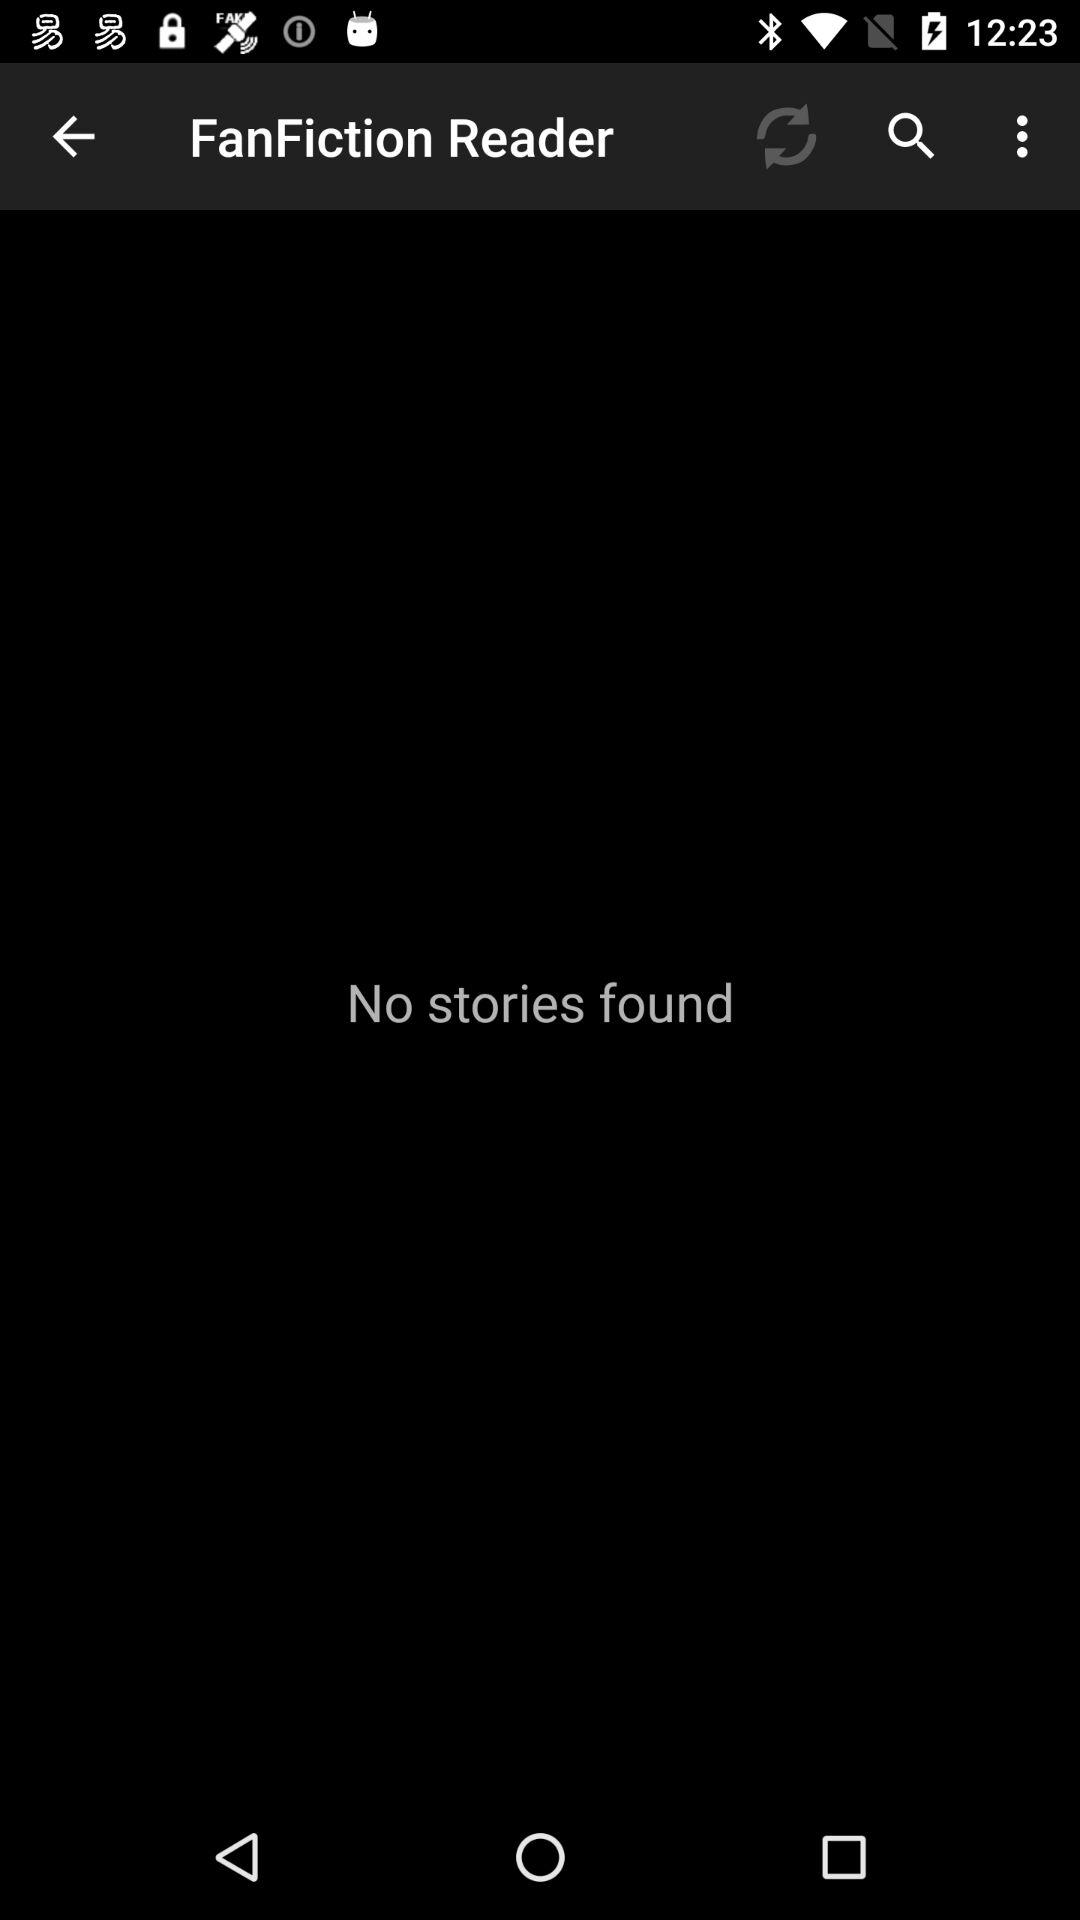What is the name of the application? The name of the application is "FanFiction Reader". 